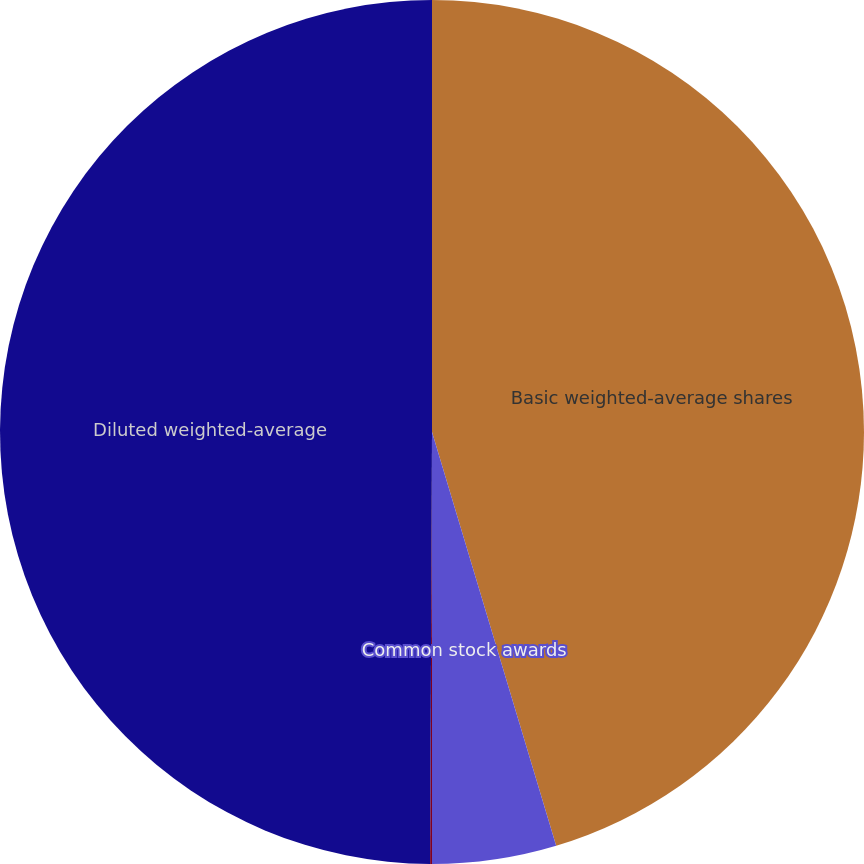<chart> <loc_0><loc_0><loc_500><loc_500><pie_chart><fcel>Basic weighted-average shares<fcel>Common stock awards<fcel>Senior subordinated<fcel>Diluted weighted-average<nl><fcel>45.36%<fcel>4.64%<fcel>0.07%<fcel>49.93%<nl></chart> 